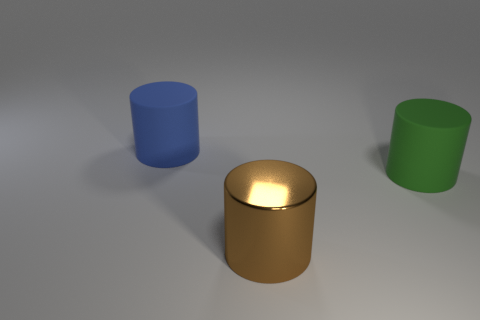Are there any other things that have the same material as the big brown thing?
Keep it short and to the point. No. What number of other objects are there of the same color as the shiny thing?
Your answer should be compact. 0. What is the size of the brown thing that is the same shape as the green matte thing?
Provide a short and direct response. Large. How many green objects are made of the same material as the big green cylinder?
Keep it short and to the point. 0. Is there a large rubber thing behind the rubber object right of the large cylinder left of the large brown thing?
Your response must be concise. Yes. There is a big blue rubber thing; what shape is it?
Ensure brevity in your answer.  Cylinder. Do the cylinder on the right side of the brown metal thing and the object in front of the green matte object have the same material?
Offer a terse response. No. What color is the cylinder that is left of the big green matte thing and in front of the big blue object?
Offer a very short reply. Brown. Is the number of rubber cylinders that are behind the large blue rubber cylinder greater than the number of brown cylinders left of the large metal cylinder?
Give a very brief answer. No. The big matte cylinder to the right of the blue matte cylinder is what color?
Offer a terse response. Green. 